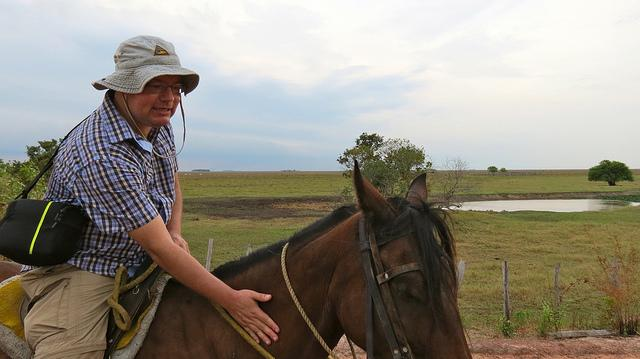What is the man trying to do to the horse? Please explain your reasoning. calm it. The man is calming it. 